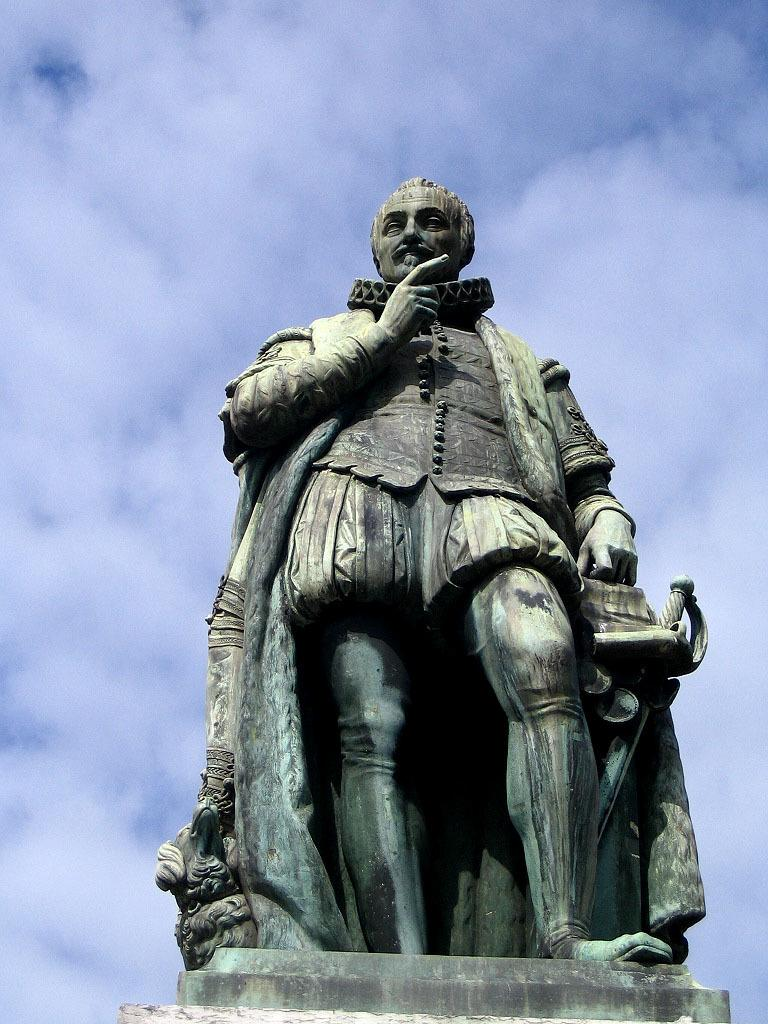What is the main subject of the image? There is a sculpture of a man standing in the image. What can be seen in the background of the image? The sky is visible in the image. What is the condition of the sky in the image? Clouds are present in the sky. Can you see the mom in the image? There is no mom present in the image; it features a sculpture of a man and a sky with clouds. 